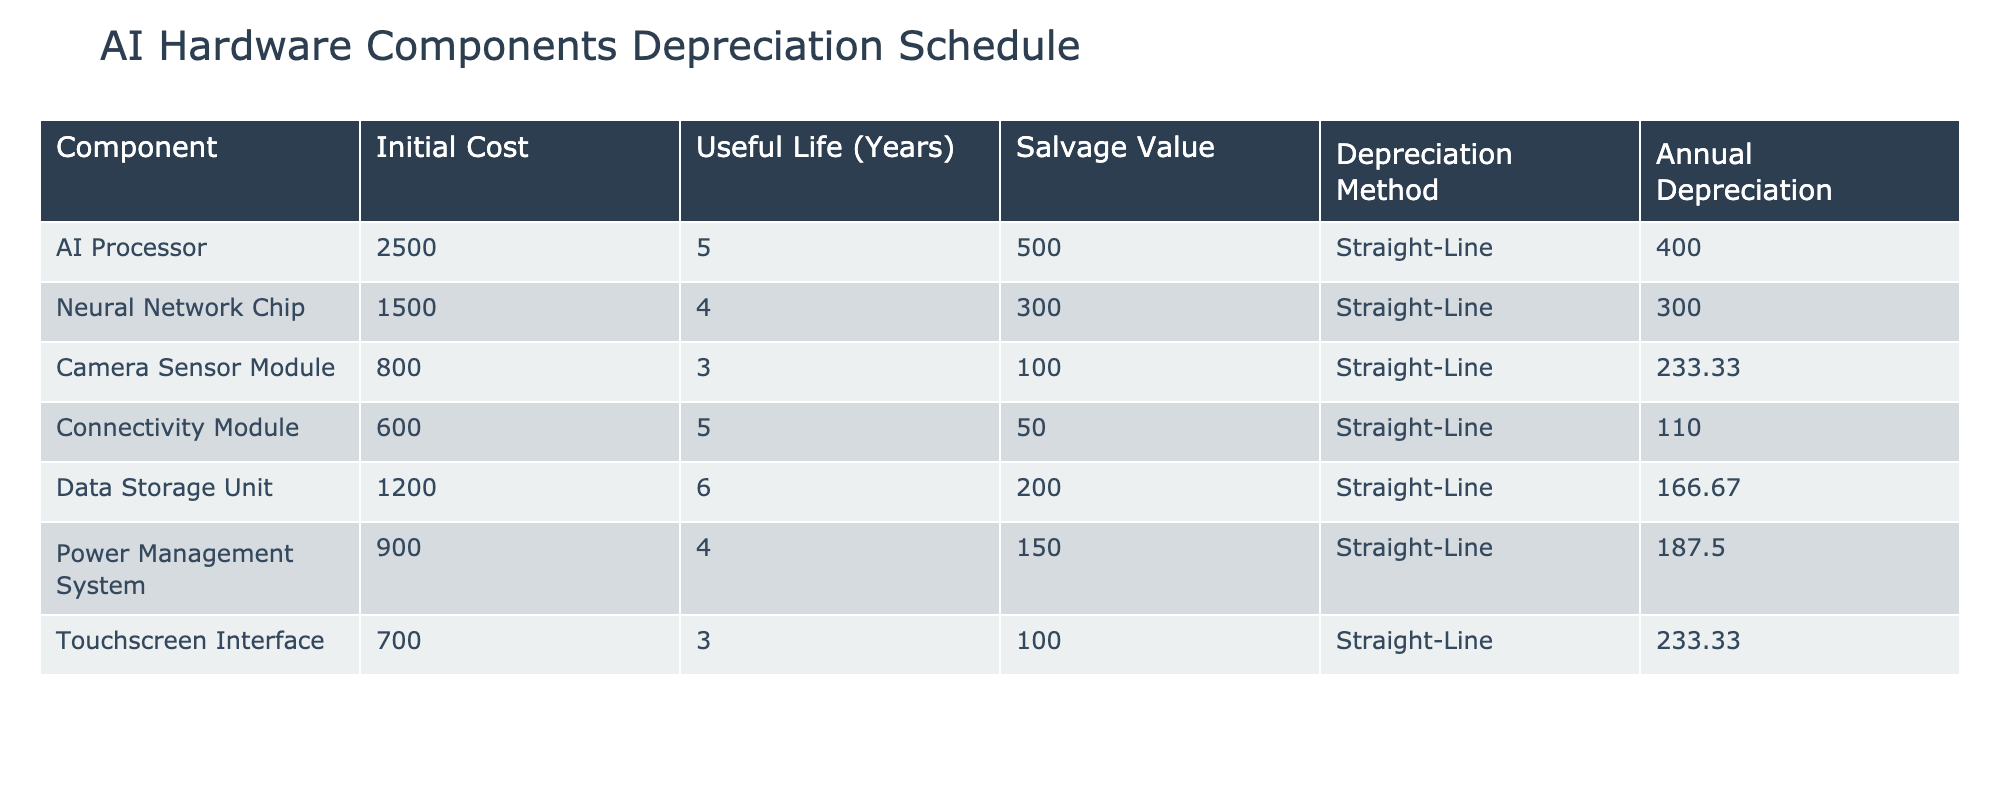What is the annual depreciation for the AI processor? The table shows the component "AI Processor" with an Annual Depreciation value listed as 400. Therefore, we can directly refer to this value.
Answer: 400 What is the useful life of the camera sensor module? Looking at the row for "Camera Sensor Module," we see the Useful Life column shows a value of 3 years. Hence, we can directly state this.
Answer: 3 years Which component has the highest annual depreciation? By reviewing the Annual Depreciation column, we see the AI Processor has a value of 400, which is greater than any other component's depreciation, indicating it has the highest annual depreciation.
Answer: AI Processor What is the total annual depreciation for all components combined? We sum the Annual Depreciation values: 400 (AI Processor) + 300 (Neural Network Chip) + 233.33 (Camera Sensor Module) + 110 (Connectivity Module) + 166.67 (Data Storage Unit) + 187.5 (Power Management System) + 233.33 (Touchscreen Interface) = 1330.83. Hence, the total is 1330.83.
Answer: 1330.83 Is the salvage value of the data storage unit greater than its annual depreciation? The Data Storage Unit has a Salvage Value of 200 and an Annual Depreciation of 166.67. Since 200 is greater than 166.67, the statement is true.
Answer: Yes Which two components have the same useful life? The rows for the “AI Processor” and “Connectivity Module” have a Useful Life of 5 years. This indicates that these two components share the same useful life duration.
Answer: AI Processor, Connectivity Module What is the average annual depreciation of all components? To calculate the average, we take the total annual depreciation (1330.83 from the previous question) and divide by the number of components, which is 7. This gives us 1330.83 / 7 = 190.12. Therefore, the average annual depreciation is 190.12.
Answer: 190.12 Is the camera sensor module's salvage value more than its initial cost? The Camera Sensor Module has an Initial Cost of 800 and a Salvage Value of 100. Since 100 is not greater than 800, the statement is false.
Answer: No Which component has the lowest salvage value, and what is that value? In the table, examining the Salvage Value column, the Connectivity Module has the lowest value at 50. Therefore, its salvage value is the lowest among all components.
Answer: 50 